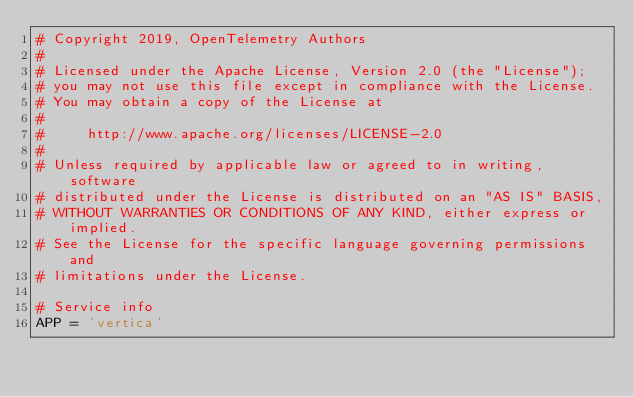<code> <loc_0><loc_0><loc_500><loc_500><_Python_># Copyright 2019, OpenTelemetry Authors
#
# Licensed under the Apache License, Version 2.0 (the "License");
# you may not use this file except in compliance with the License.
# You may obtain a copy of the License at
#
#     http://www.apache.org/licenses/LICENSE-2.0
#
# Unless required by applicable law or agreed to in writing, software
# distributed under the License is distributed on an "AS IS" BASIS,
# WITHOUT WARRANTIES OR CONDITIONS OF ANY KIND, either express or implied.
# See the License for the specific language governing permissions and
# limitations under the License.

# Service info
APP = 'vertica'
</code> 